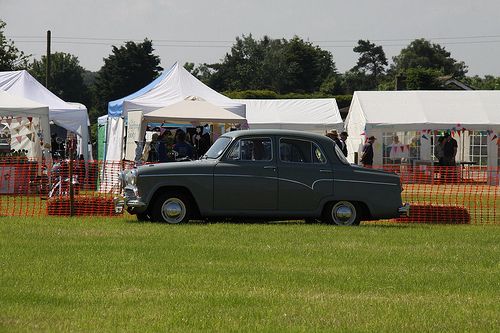<image>
Is there a car in front of the tent? Yes. The car is positioned in front of the tent, appearing closer to the camera viewpoint. 